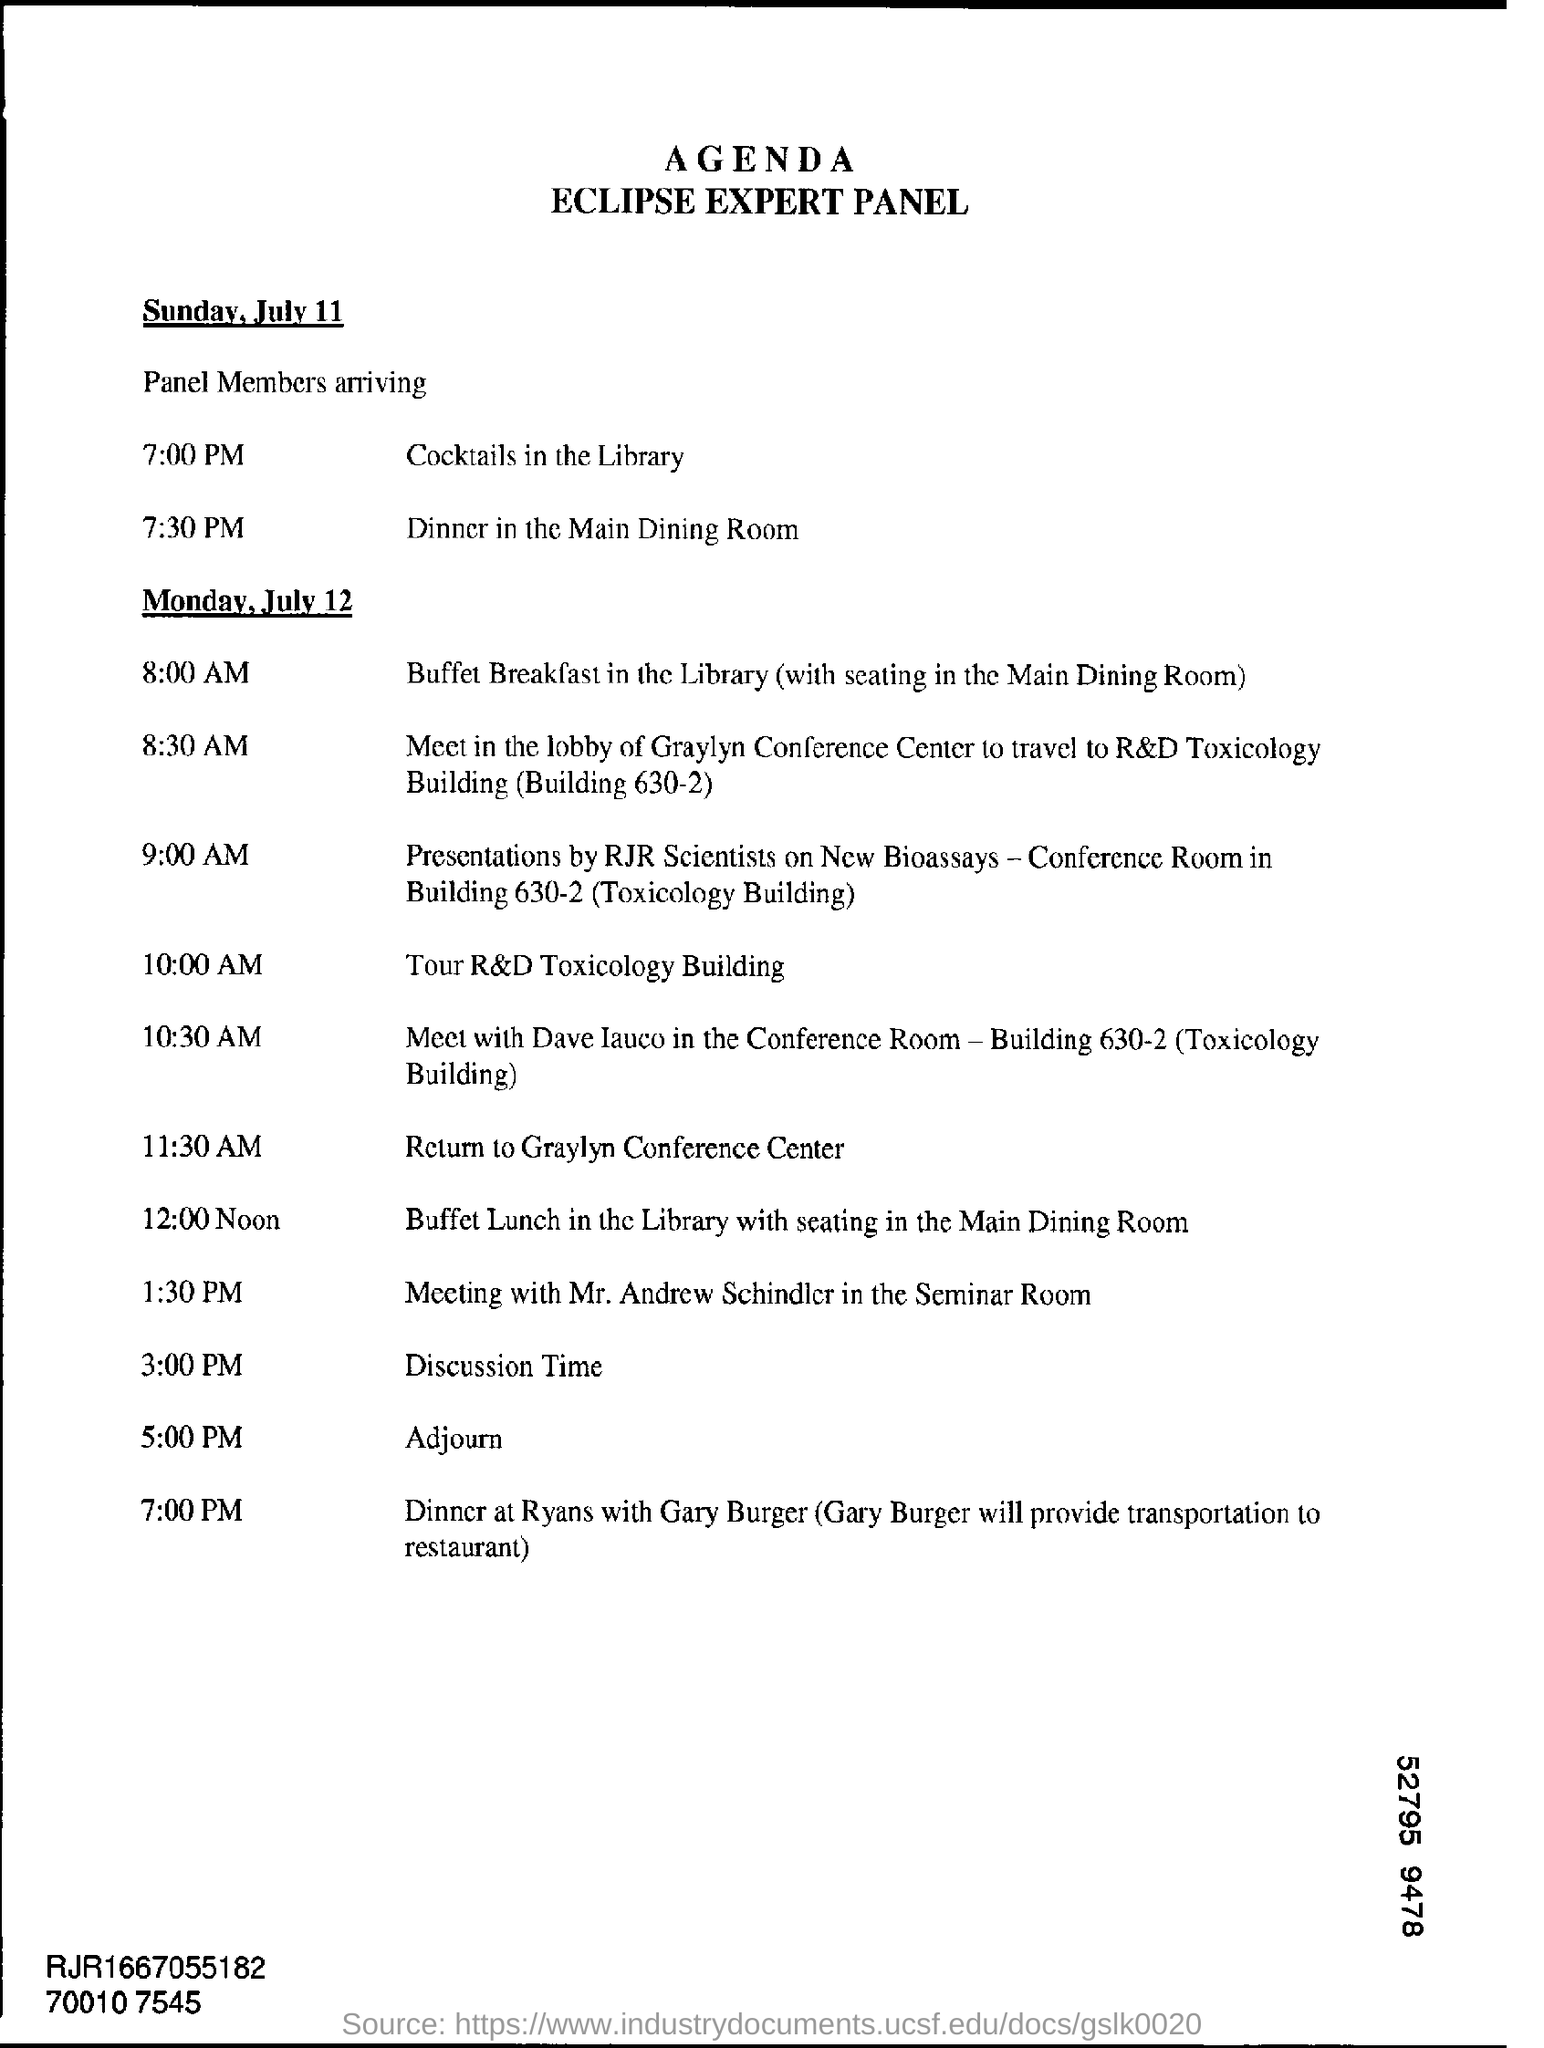What is the name of panel?
Your answer should be very brief. Eclipse expert panel. On which day meeting with mr.andrew schindler in the seminar room?
Provide a short and direct response. Monday,July 12. 